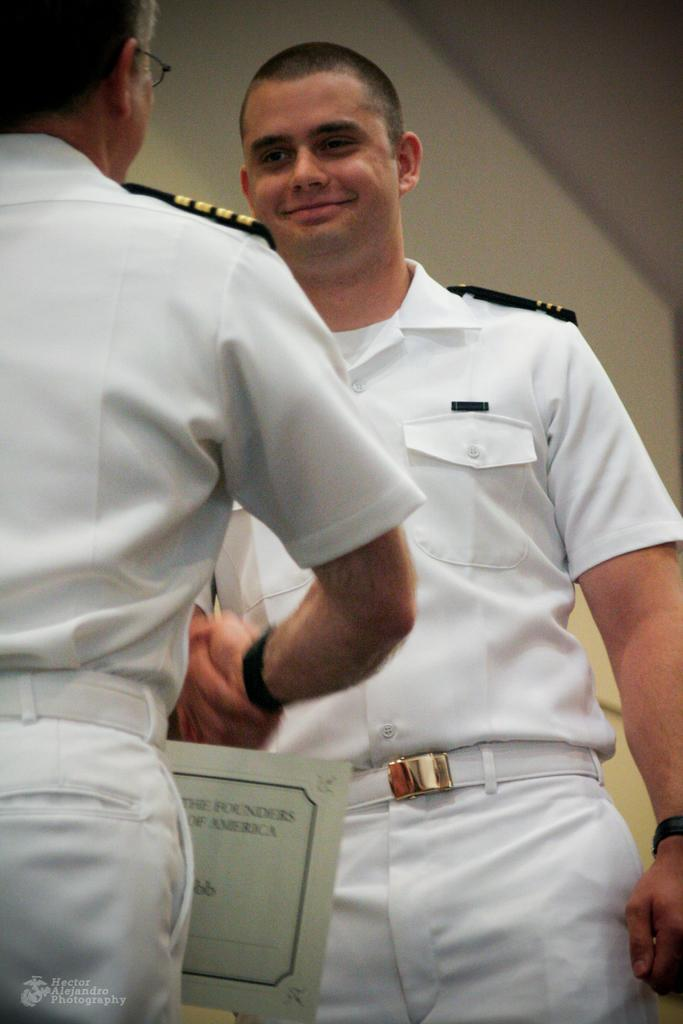How many people are in the image? There are two people in the image. What are the two people doing? The two people are standing and shaking hands. What are the people wearing? The people are wearing uniforms. What can be seen in the image besides the people? There is a board and a wall in the background of the image. What advice is the vase giving to the people in the image? There is no vase present in the image, so it cannot provide any advice. 